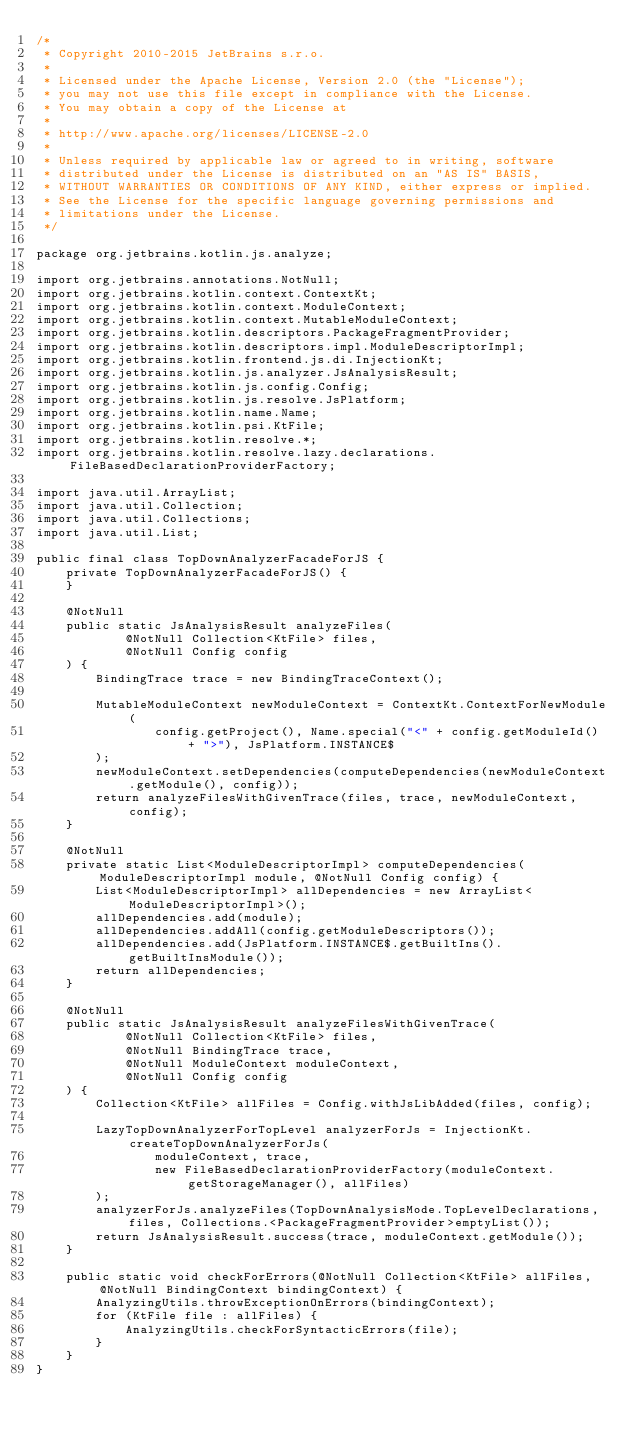<code> <loc_0><loc_0><loc_500><loc_500><_Java_>/*
 * Copyright 2010-2015 JetBrains s.r.o.
 *
 * Licensed under the Apache License, Version 2.0 (the "License");
 * you may not use this file except in compliance with the License.
 * You may obtain a copy of the License at
 *
 * http://www.apache.org/licenses/LICENSE-2.0
 *
 * Unless required by applicable law or agreed to in writing, software
 * distributed under the License is distributed on an "AS IS" BASIS,
 * WITHOUT WARRANTIES OR CONDITIONS OF ANY KIND, either express or implied.
 * See the License for the specific language governing permissions and
 * limitations under the License.
 */

package org.jetbrains.kotlin.js.analyze;

import org.jetbrains.annotations.NotNull;
import org.jetbrains.kotlin.context.ContextKt;
import org.jetbrains.kotlin.context.ModuleContext;
import org.jetbrains.kotlin.context.MutableModuleContext;
import org.jetbrains.kotlin.descriptors.PackageFragmentProvider;
import org.jetbrains.kotlin.descriptors.impl.ModuleDescriptorImpl;
import org.jetbrains.kotlin.frontend.js.di.InjectionKt;
import org.jetbrains.kotlin.js.analyzer.JsAnalysisResult;
import org.jetbrains.kotlin.js.config.Config;
import org.jetbrains.kotlin.js.resolve.JsPlatform;
import org.jetbrains.kotlin.name.Name;
import org.jetbrains.kotlin.psi.KtFile;
import org.jetbrains.kotlin.resolve.*;
import org.jetbrains.kotlin.resolve.lazy.declarations.FileBasedDeclarationProviderFactory;

import java.util.ArrayList;
import java.util.Collection;
import java.util.Collections;
import java.util.List;

public final class TopDownAnalyzerFacadeForJS {
    private TopDownAnalyzerFacadeForJS() {
    }

    @NotNull
    public static JsAnalysisResult analyzeFiles(
            @NotNull Collection<KtFile> files,
            @NotNull Config config
    ) {
        BindingTrace trace = new BindingTraceContext();

        MutableModuleContext newModuleContext = ContextKt.ContextForNewModule(
                config.getProject(), Name.special("<" + config.getModuleId() + ">"), JsPlatform.INSTANCE$
        );
        newModuleContext.setDependencies(computeDependencies(newModuleContext.getModule(), config));
        return analyzeFilesWithGivenTrace(files, trace, newModuleContext, config);
    }

    @NotNull
    private static List<ModuleDescriptorImpl> computeDependencies(ModuleDescriptorImpl module, @NotNull Config config) {
        List<ModuleDescriptorImpl> allDependencies = new ArrayList<ModuleDescriptorImpl>();
        allDependencies.add(module);
        allDependencies.addAll(config.getModuleDescriptors());
        allDependencies.add(JsPlatform.INSTANCE$.getBuiltIns().getBuiltInsModule());
        return allDependencies;
    }

    @NotNull
    public static JsAnalysisResult analyzeFilesWithGivenTrace(
            @NotNull Collection<KtFile> files,
            @NotNull BindingTrace trace,
            @NotNull ModuleContext moduleContext,
            @NotNull Config config
    ) {
        Collection<KtFile> allFiles = Config.withJsLibAdded(files, config);

        LazyTopDownAnalyzerForTopLevel analyzerForJs = InjectionKt.createTopDownAnalyzerForJs(
                moduleContext, trace,
                new FileBasedDeclarationProviderFactory(moduleContext.getStorageManager(), allFiles)
        );
        analyzerForJs.analyzeFiles(TopDownAnalysisMode.TopLevelDeclarations, files, Collections.<PackageFragmentProvider>emptyList());
        return JsAnalysisResult.success(trace, moduleContext.getModule());
    }

    public static void checkForErrors(@NotNull Collection<KtFile> allFiles, @NotNull BindingContext bindingContext) {
        AnalyzingUtils.throwExceptionOnErrors(bindingContext);
        for (KtFile file : allFiles) {
            AnalyzingUtils.checkForSyntacticErrors(file);
        }
    }
}
</code> 